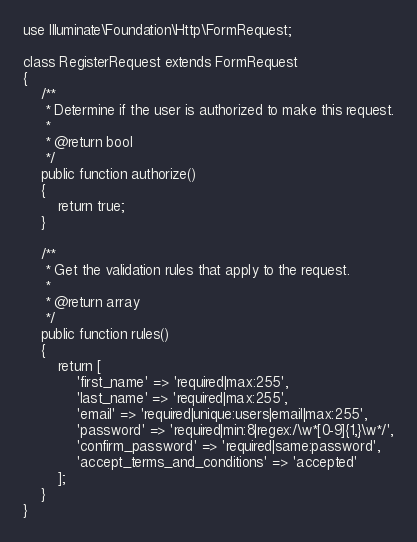<code> <loc_0><loc_0><loc_500><loc_500><_PHP_>
use Illuminate\Foundation\Http\FormRequest;

class RegisterRequest extends FormRequest
{
    /**
     * Determine if the user is authorized to make this request.
     *
     * @return bool
     */
    public function authorize()
    {
        return true;
    }

    /**
     * Get the validation rules that apply to the request.
     *
     * @return array
     */
    public function rules()
    {
        return [
            'first_name' => 'required|max:255',
            'last_name' => 'required|max:255',
            'email' => 'required|unique:users|email|max:255',
            'password' => 'required|min:8|regex:/\w*[0-9]{1,}\w*/',
            'confirm_password' => 'required|same:password',
            'accept_terms_and_conditions' => 'accepted'
        ];
    }
}
</code> 